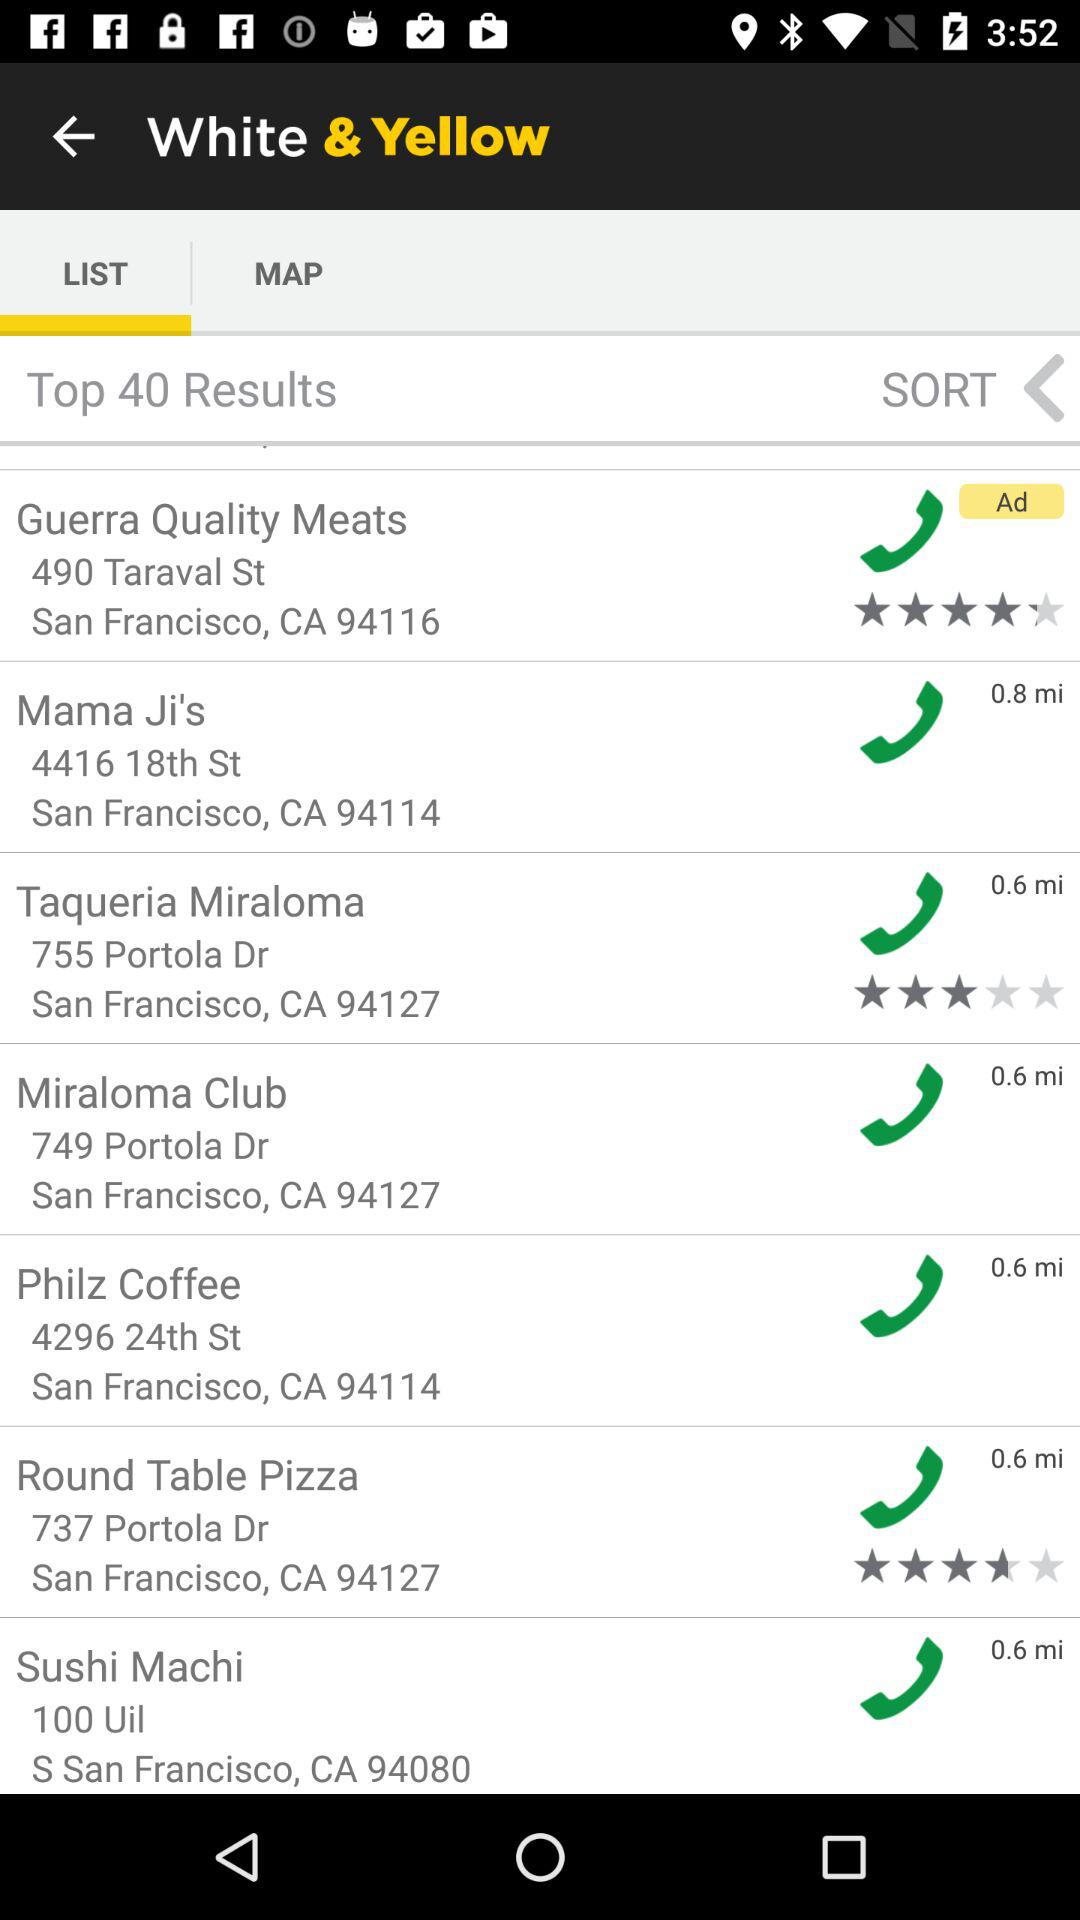What is the location of "Philz Coffee"? The location is 4296 24th Street, San Francisco, CA 94114. 